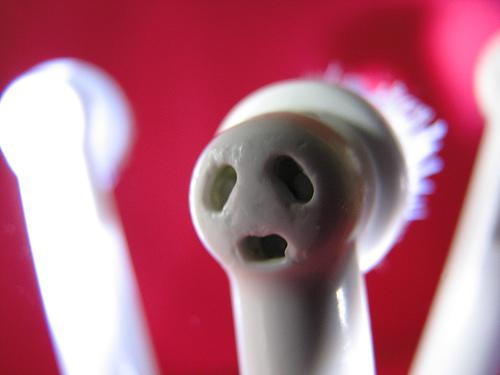Question: what is the color of the wall?
Choices:
A. Red.
B. Orange.
C. Yellow.
D. Pink.
Answer with the letter. Answer: D Question: when is the picture taken?
Choices:
A. Daytime.
B. At night.
C. At dawn.
D. At dusk.
Answer with the letter. Answer: A 